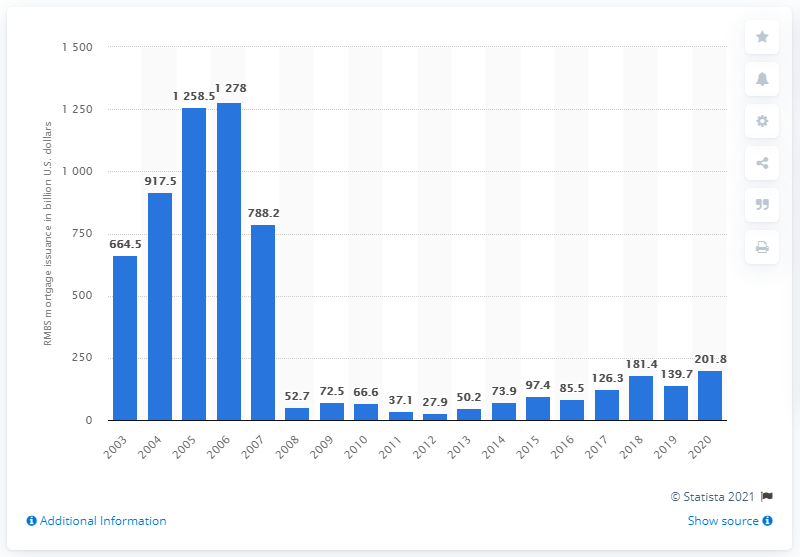Outline some significant characteristics in this image. In 2006, the value of residential mortgage-backed securities in the United States was 1,278 in US dollars. In 2020, the total amount of mortgage-backed securities backed by U.S. dollars was 201.8... 